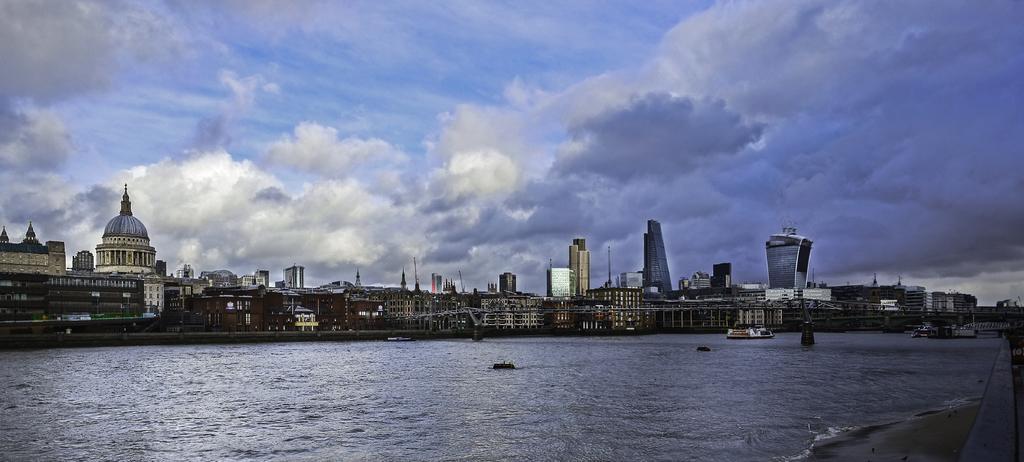How would you summarize this image in a sentence or two? In this image, we can see a beach. There are some buildings in the middle of the image. There are clouds in the sky. 